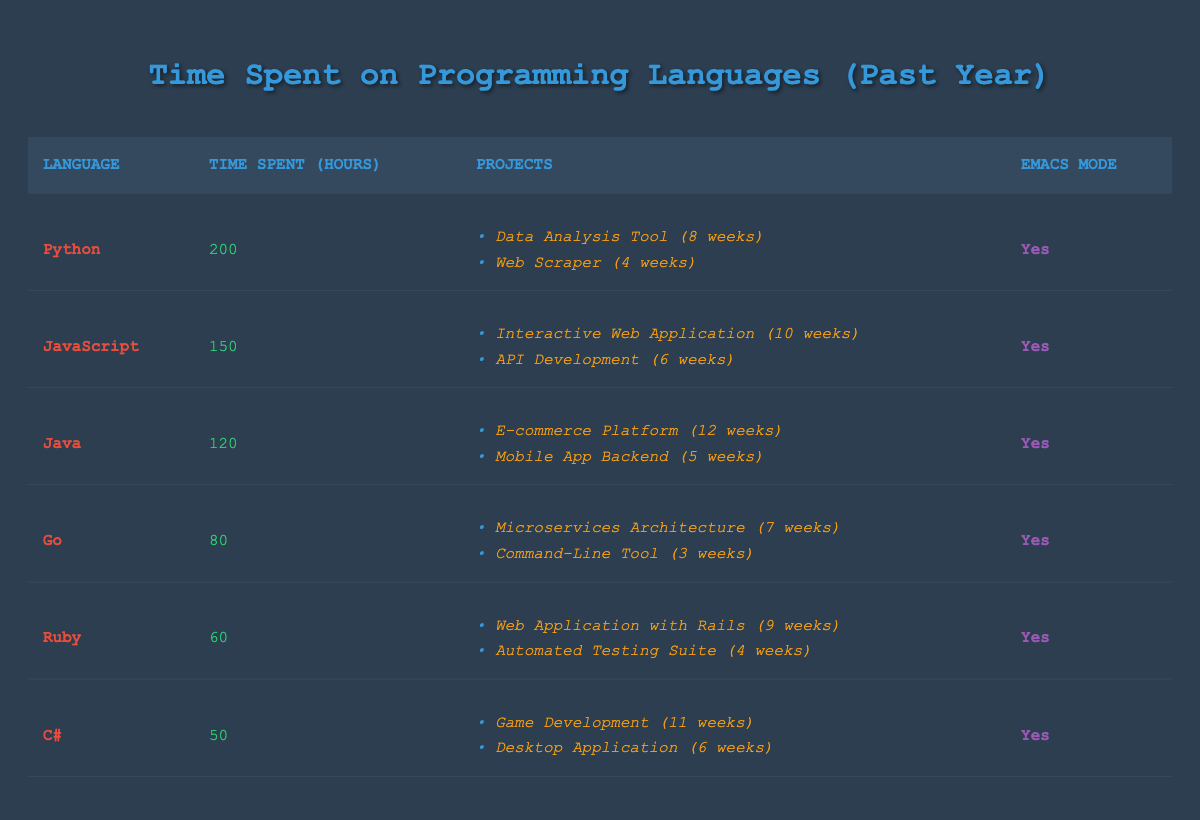What programming language had the highest time spent? Looking at the time spent hours for each language, Python had the highest at 200 hours, followed by JavaScript at 150 hours.
Answer: Python How many hours were spent on Java and C# combined? Java spent 120 hours and C# spent 50 hours. The combined total is 120 + 50 = 170 hours.
Answer: 170 hours Is Emacs mode used for all programming languages listed? Each programming language row in the table indicates "Yes" under Emacs mode, confirming that all languages had Emacs mode enabled.
Answer: Yes What is the average time spent on programming languages that had Emacs mode? All languages are in Emacs mode, so we calculate the average: (200 + 150 + 120 + 80 + 60 + 50) = 660 hours. There are 6 languages, so 660 / 6 = 110 hours.
Answer: 110 hours Which project took the longest time in weeks? Referring to the project durations in weeks, the longest is "E-commerce Platform" with 12 weeks, followed by "Game Development" and "Interactive Web Application" at 11 and 10 weeks respectively.
Answer: E-commerce Platform What percentage of time was spent on Python compared to the total hours spent on all languages? The total time spent on all languages is 660 hours. The percentage of Python time is (200 / 660) * 100 = 30.3%.
Answer: 30.3% How many projects were completed using Java? Under the Java row, there are two projects listed: "E-commerce Platform" and "Mobile App Backend." So there were 2 projects completed.
Answer: 2 projects If we only consider Python and Go, what is the difference in time spent? For Python 200 hours and Go 80 hours. The difference is 200 - 80 = 120 hours.
Answer: 120 hours What is the total time spent on JavaScript and Ruby? The time spent on JavaScript is 150 hours and Ruby is 60 hours. The total is 150 + 60 = 210 hours.
Answer: 210 hours Which programming language's projects had the shortest combined duration? The combined project duration for C# is 11 weeks (Game Development) + 6 weeks (Desktop Application) which equals 17 weeks. Meanwhile, Ruby has a total of 13 weeks, and Go has 10 weeks, making Go's projects the shortest.
Answer: Go 